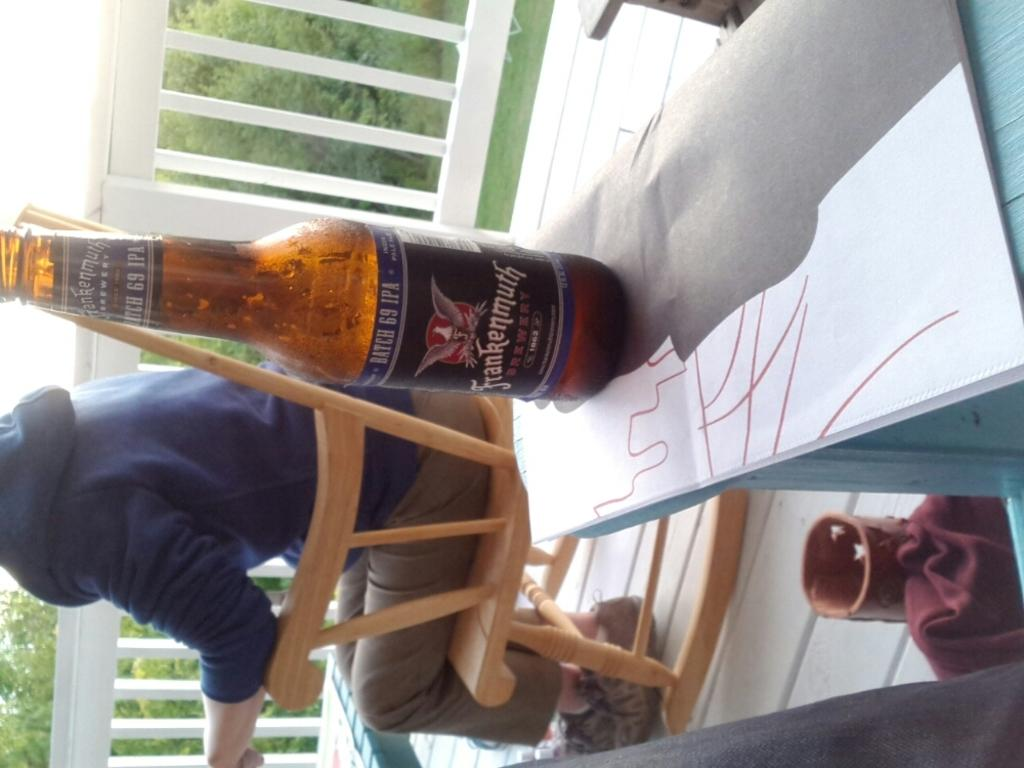<image>
Share a concise interpretation of the image provided. A beer bottle label indicates that the product has a Batch 69 IPA. 